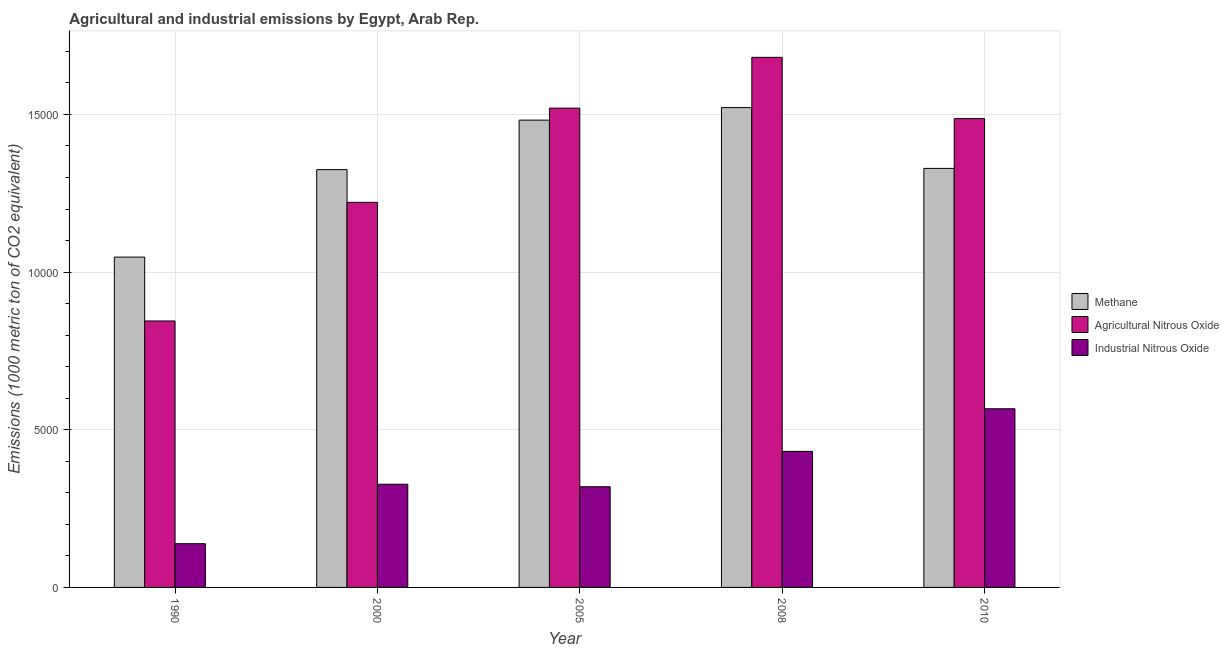How many groups of bars are there?
Give a very brief answer. 5. Are the number of bars per tick equal to the number of legend labels?
Keep it short and to the point. Yes. How many bars are there on the 3rd tick from the left?
Provide a succinct answer. 3. How many bars are there on the 5th tick from the right?
Make the answer very short. 3. What is the amount of methane emissions in 2000?
Offer a very short reply. 1.33e+04. Across all years, what is the maximum amount of agricultural nitrous oxide emissions?
Provide a succinct answer. 1.68e+04. Across all years, what is the minimum amount of agricultural nitrous oxide emissions?
Ensure brevity in your answer.  8449.9. What is the total amount of agricultural nitrous oxide emissions in the graph?
Provide a short and direct response. 6.75e+04. What is the difference between the amount of industrial nitrous oxide emissions in 1990 and that in 2000?
Ensure brevity in your answer.  -1886.1. What is the difference between the amount of agricultural nitrous oxide emissions in 2010 and the amount of methane emissions in 2005?
Make the answer very short. -331.2. What is the average amount of agricultural nitrous oxide emissions per year?
Offer a terse response. 1.35e+04. In how many years, is the amount of agricultural nitrous oxide emissions greater than 6000 metric ton?
Your answer should be compact. 5. What is the ratio of the amount of methane emissions in 2008 to that in 2010?
Your answer should be compact. 1.15. Is the amount of agricultural nitrous oxide emissions in 2005 less than that in 2008?
Make the answer very short. Yes. Is the difference between the amount of agricultural nitrous oxide emissions in 1990 and 2000 greater than the difference between the amount of methane emissions in 1990 and 2000?
Give a very brief answer. No. What is the difference between the highest and the second highest amount of agricultural nitrous oxide emissions?
Offer a very short reply. 1611.4. What is the difference between the highest and the lowest amount of agricultural nitrous oxide emissions?
Give a very brief answer. 8361.5. In how many years, is the amount of agricultural nitrous oxide emissions greater than the average amount of agricultural nitrous oxide emissions taken over all years?
Give a very brief answer. 3. Is the sum of the amount of methane emissions in 1990 and 2000 greater than the maximum amount of agricultural nitrous oxide emissions across all years?
Offer a terse response. Yes. What does the 1st bar from the left in 2010 represents?
Offer a very short reply. Methane. What does the 1st bar from the right in 2010 represents?
Offer a terse response. Industrial Nitrous Oxide. Is it the case that in every year, the sum of the amount of methane emissions and amount of agricultural nitrous oxide emissions is greater than the amount of industrial nitrous oxide emissions?
Offer a terse response. Yes. How many bars are there?
Your answer should be compact. 15. Does the graph contain any zero values?
Offer a terse response. No. How are the legend labels stacked?
Your response must be concise. Vertical. What is the title of the graph?
Your response must be concise. Agricultural and industrial emissions by Egypt, Arab Rep. What is the label or title of the X-axis?
Offer a very short reply. Year. What is the label or title of the Y-axis?
Provide a short and direct response. Emissions (1000 metric ton of CO2 equivalent). What is the Emissions (1000 metric ton of CO2 equivalent) of Methane in 1990?
Give a very brief answer. 1.05e+04. What is the Emissions (1000 metric ton of CO2 equivalent) in Agricultural Nitrous Oxide in 1990?
Make the answer very short. 8449.9. What is the Emissions (1000 metric ton of CO2 equivalent) in Industrial Nitrous Oxide in 1990?
Make the answer very short. 1386.6. What is the Emissions (1000 metric ton of CO2 equivalent) of Methane in 2000?
Your response must be concise. 1.33e+04. What is the Emissions (1000 metric ton of CO2 equivalent) in Agricultural Nitrous Oxide in 2000?
Offer a terse response. 1.22e+04. What is the Emissions (1000 metric ton of CO2 equivalent) of Industrial Nitrous Oxide in 2000?
Provide a succinct answer. 3272.7. What is the Emissions (1000 metric ton of CO2 equivalent) in Methane in 2005?
Provide a succinct answer. 1.48e+04. What is the Emissions (1000 metric ton of CO2 equivalent) of Agricultural Nitrous Oxide in 2005?
Offer a very short reply. 1.52e+04. What is the Emissions (1000 metric ton of CO2 equivalent) of Industrial Nitrous Oxide in 2005?
Offer a very short reply. 3192.6. What is the Emissions (1000 metric ton of CO2 equivalent) of Methane in 2008?
Provide a short and direct response. 1.52e+04. What is the Emissions (1000 metric ton of CO2 equivalent) in Agricultural Nitrous Oxide in 2008?
Your response must be concise. 1.68e+04. What is the Emissions (1000 metric ton of CO2 equivalent) in Industrial Nitrous Oxide in 2008?
Give a very brief answer. 4315. What is the Emissions (1000 metric ton of CO2 equivalent) in Methane in 2010?
Your answer should be compact. 1.33e+04. What is the Emissions (1000 metric ton of CO2 equivalent) in Agricultural Nitrous Oxide in 2010?
Provide a succinct answer. 1.49e+04. What is the Emissions (1000 metric ton of CO2 equivalent) of Industrial Nitrous Oxide in 2010?
Provide a short and direct response. 5666.2. Across all years, what is the maximum Emissions (1000 metric ton of CO2 equivalent) of Methane?
Offer a terse response. 1.52e+04. Across all years, what is the maximum Emissions (1000 metric ton of CO2 equivalent) of Agricultural Nitrous Oxide?
Your answer should be very brief. 1.68e+04. Across all years, what is the maximum Emissions (1000 metric ton of CO2 equivalent) in Industrial Nitrous Oxide?
Your answer should be compact. 5666.2. Across all years, what is the minimum Emissions (1000 metric ton of CO2 equivalent) in Methane?
Offer a terse response. 1.05e+04. Across all years, what is the minimum Emissions (1000 metric ton of CO2 equivalent) of Agricultural Nitrous Oxide?
Provide a succinct answer. 8449.9. Across all years, what is the minimum Emissions (1000 metric ton of CO2 equivalent) in Industrial Nitrous Oxide?
Give a very brief answer. 1386.6. What is the total Emissions (1000 metric ton of CO2 equivalent) of Methane in the graph?
Your answer should be very brief. 6.71e+04. What is the total Emissions (1000 metric ton of CO2 equivalent) of Agricultural Nitrous Oxide in the graph?
Ensure brevity in your answer.  6.75e+04. What is the total Emissions (1000 metric ton of CO2 equivalent) of Industrial Nitrous Oxide in the graph?
Ensure brevity in your answer.  1.78e+04. What is the difference between the Emissions (1000 metric ton of CO2 equivalent) in Methane in 1990 and that in 2000?
Provide a succinct answer. -2774.9. What is the difference between the Emissions (1000 metric ton of CO2 equivalent) of Agricultural Nitrous Oxide in 1990 and that in 2000?
Your answer should be compact. -3762.5. What is the difference between the Emissions (1000 metric ton of CO2 equivalent) in Industrial Nitrous Oxide in 1990 and that in 2000?
Provide a succinct answer. -1886.1. What is the difference between the Emissions (1000 metric ton of CO2 equivalent) of Methane in 1990 and that in 2005?
Give a very brief answer. -4343.8. What is the difference between the Emissions (1000 metric ton of CO2 equivalent) of Agricultural Nitrous Oxide in 1990 and that in 2005?
Give a very brief answer. -6750.1. What is the difference between the Emissions (1000 metric ton of CO2 equivalent) of Industrial Nitrous Oxide in 1990 and that in 2005?
Provide a succinct answer. -1806. What is the difference between the Emissions (1000 metric ton of CO2 equivalent) of Methane in 1990 and that in 2008?
Provide a succinct answer. -4741.1. What is the difference between the Emissions (1000 metric ton of CO2 equivalent) in Agricultural Nitrous Oxide in 1990 and that in 2008?
Provide a short and direct response. -8361.5. What is the difference between the Emissions (1000 metric ton of CO2 equivalent) of Industrial Nitrous Oxide in 1990 and that in 2008?
Provide a short and direct response. -2928.4. What is the difference between the Emissions (1000 metric ton of CO2 equivalent) in Methane in 1990 and that in 2010?
Provide a short and direct response. -2813. What is the difference between the Emissions (1000 metric ton of CO2 equivalent) of Agricultural Nitrous Oxide in 1990 and that in 2010?
Make the answer very short. -6418.9. What is the difference between the Emissions (1000 metric ton of CO2 equivalent) in Industrial Nitrous Oxide in 1990 and that in 2010?
Keep it short and to the point. -4279.6. What is the difference between the Emissions (1000 metric ton of CO2 equivalent) of Methane in 2000 and that in 2005?
Your answer should be compact. -1568.9. What is the difference between the Emissions (1000 metric ton of CO2 equivalent) in Agricultural Nitrous Oxide in 2000 and that in 2005?
Provide a succinct answer. -2987.6. What is the difference between the Emissions (1000 metric ton of CO2 equivalent) in Industrial Nitrous Oxide in 2000 and that in 2005?
Keep it short and to the point. 80.1. What is the difference between the Emissions (1000 metric ton of CO2 equivalent) in Methane in 2000 and that in 2008?
Keep it short and to the point. -1966.2. What is the difference between the Emissions (1000 metric ton of CO2 equivalent) of Agricultural Nitrous Oxide in 2000 and that in 2008?
Provide a short and direct response. -4599. What is the difference between the Emissions (1000 metric ton of CO2 equivalent) of Industrial Nitrous Oxide in 2000 and that in 2008?
Offer a terse response. -1042.3. What is the difference between the Emissions (1000 metric ton of CO2 equivalent) in Methane in 2000 and that in 2010?
Provide a succinct answer. -38.1. What is the difference between the Emissions (1000 metric ton of CO2 equivalent) of Agricultural Nitrous Oxide in 2000 and that in 2010?
Provide a short and direct response. -2656.4. What is the difference between the Emissions (1000 metric ton of CO2 equivalent) of Industrial Nitrous Oxide in 2000 and that in 2010?
Ensure brevity in your answer.  -2393.5. What is the difference between the Emissions (1000 metric ton of CO2 equivalent) of Methane in 2005 and that in 2008?
Your answer should be compact. -397.3. What is the difference between the Emissions (1000 metric ton of CO2 equivalent) in Agricultural Nitrous Oxide in 2005 and that in 2008?
Keep it short and to the point. -1611.4. What is the difference between the Emissions (1000 metric ton of CO2 equivalent) of Industrial Nitrous Oxide in 2005 and that in 2008?
Offer a very short reply. -1122.4. What is the difference between the Emissions (1000 metric ton of CO2 equivalent) in Methane in 2005 and that in 2010?
Make the answer very short. 1530.8. What is the difference between the Emissions (1000 metric ton of CO2 equivalent) of Agricultural Nitrous Oxide in 2005 and that in 2010?
Your answer should be compact. 331.2. What is the difference between the Emissions (1000 metric ton of CO2 equivalent) in Industrial Nitrous Oxide in 2005 and that in 2010?
Your answer should be compact. -2473.6. What is the difference between the Emissions (1000 metric ton of CO2 equivalent) of Methane in 2008 and that in 2010?
Give a very brief answer. 1928.1. What is the difference between the Emissions (1000 metric ton of CO2 equivalent) of Agricultural Nitrous Oxide in 2008 and that in 2010?
Offer a terse response. 1942.6. What is the difference between the Emissions (1000 metric ton of CO2 equivalent) in Industrial Nitrous Oxide in 2008 and that in 2010?
Offer a terse response. -1351.2. What is the difference between the Emissions (1000 metric ton of CO2 equivalent) of Methane in 1990 and the Emissions (1000 metric ton of CO2 equivalent) of Agricultural Nitrous Oxide in 2000?
Your answer should be very brief. -1736.3. What is the difference between the Emissions (1000 metric ton of CO2 equivalent) in Methane in 1990 and the Emissions (1000 metric ton of CO2 equivalent) in Industrial Nitrous Oxide in 2000?
Provide a succinct answer. 7203.4. What is the difference between the Emissions (1000 metric ton of CO2 equivalent) in Agricultural Nitrous Oxide in 1990 and the Emissions (1000 metric ton of CO2 equivalent) in Industrial Nitrous Oxide in 2000?
Provide a succinct answer. 5177.2. What is the difference between the Emissions (1000 metric ton of CO2 equivalent) of Methane in 1990 and the Emissions (1000 metric ton of CO2 equivalent) of Agricultural Nitrous Oxide in 2005?
Offer a terse response. -4723.9. What is the difference between the Emissions (1000 metric ton of CO2 equivalent) in Methane in 1990 and the Emissions (1000 metric ton of CO2 equivalent) in Industrial Nitrous Oxide in 2005?
Offer a terse response. 7283.5. What is the difference between the Emissions (1000 metric ton of CO2 equivalent) of Agricultural Nitrous Oxide in 1990 and the Emissions (1000 metric ton of CO2 equivalent) of Industrial Nitrous Oxide in 2005?
Ensure brevity in your answer.  5257.3. What is the difference between the Emissions (1000 metric ton of CO2 equivalent) of Methane in 1990 and the Emissions (1000 metric ton of CO2 equivalent) of Agricultural Nitrous Oxide in 2008?
Keep it short and to the point. -6335.3. What is the difference between the Emissions (1000 metric ton of CO2 equivalent) in Methane in 1990 and the Emissions (1000 metric ton of CO2 equivalent) in Industrial Nitrous Oxide in 2008?
Keep it short and to the point. 6161.1. What is the difference between the Emissions (1000 metric ton of CO2 equivalent) of Agricultural Nitrous Oxide in 1990 and the Emissions (1000 metric ton of CO2 equivalent) of Industrial Nitrous Oxide in 2008?
Provide a short and direct response. 4134.9. What is the difference between the Emissions (1000 metric ton of CO2 equivalent) of Methane in 1990 and the Emissions (1000 metric ton of CO2 equivalent) of Agricultural Nitrous Oxide in 2010?
Your answer should be very brief. -4392.7. What is the difference between the Emissions (1000 metric ton of CO2 equivalent) in Methane in 1990 and the Emissions (1000 metric ton of CO2 equivalent) in Industrial Nitrous Oxide in 2010?
Your answer should be very brief. 4809.9. What is the difference between the Emissions (1000 metric ton of CO2 equivalent) of Agricultural Nitrous Oxide in 1990 and the Emissions (1000 metric ton of CO2 equivalent) of Industrial Nitrous Oxide in 2010?
Your answer should be very brief. 2783.7. What is the difference between the Emissions (1000 metric ton of CO2 equivalent) of Methane in 2000 and the Emissions (1000 metric ton of CO2 equivalent) of Agricultural Nitrous Oxide in 2005?
Give a very brief answer. -1949. What is the difference between the Emissions (1000 metric ton of CO2 equivalent) in Methane in 2000 and the Emissions (1000 metric ton of CO2 equivalent) in Industrial Nitrous Oxide in 2005?
Provide a succinct answer. 1.01e+04. What is the difference between the Emissions (1000 metric ton of CO2 equivalent) of Agricultural Nitrous Oxide in 2000 and the Emissions (1000 metric ton of CO2 equivalent) of Industrial Nitrous Oxide in 2005?
Ensure brevity in your answer.  9019.8. What is the difference between the Emissions (1000 metric ton of CO2 equivalent) of Methane in 2000 and the Emissions (1000 metric ton of CO2 equivalent) of Agricultural Nitrous Oxide in 2008?
Your answer should be compact. -3560.4. What is the difference between the Emissions (1000 metric ton of CO2 equivalent) of Methane in 2000 and the Emissions (1000 metric ton of CO2 equivalent) of Industrial Nitrous Oxide in 2008?
Your answer should be very brief. 8936. What is the difference between the Emissions (1000 metric ton of CO2 equivalent) in Agricultural Nitrous Oxide in 2000 and the Emissions (1000 metric ton of CO2 equivalent) in Industrial Nitrous Oxide in 2008?
Your answer should be very brief. 7897.4. What is the difference between the Emissions (1000 metric ton of CO2 equivalent) of Methane in 2000 and the Emissions (1000 metric ton of CO2 equivalent) of Agricultural Nitrous Oxide in 2010?
Your answer should be very brief. -1617.8. What is the difference between the Emissions (1000 metric ton of CO2 equivalent) in Methane in 2000 and the Emissions (1000 metric ton of CO2 equivalent) in Industrial Nitrous Oxide in 2010?
Your answer should be very brief. 7584.8. What is the difference between the Emissions (1000 metric ton of CO2 equivalent) of Agricultural Nitrous Oxide in 2000 and the Emissions (1000 metric ton of CO2 equivalent) of Industrial Nitrous Oxide in 2010?
Offer a terse response. 6546.2. What is the difference between the Emissions (1000 metric ton of CO2 equivalent) of Methane in 2005 and the Emissions (1000 metric ton of CO2 equivalent) of Agricultural Nitrous Oxide in 2008?
Ensure brevity in your answer.  -1991.5. What is the difference between the Emissions (1000 metric ton of CO2 equivalent) of Methane in 2005 and the Emissions (1000 metric ton of CO2 equivalent) of Industrial Nitrous Oxide in 2008?
Offer a very short reply. 1.05e+04. What is the difference between the Emissions (1000 metric ton of CO2 equivalent) in Agricultural Nitrous Oxide in 2005 and the Emissions (1000 metric ton of CO2 equivalent) in Industrial Nitrous Oxide in 2008?
Provide a short and direct response. 1.09e+04. What is the difference between the Emissions (1000 metric ton of CO2 equivalent) in Methane in 2005 and the Emissions (1000 metric ton of CO2 equivalent) in Agricultural Nitrous Oxide in 2010?
Offer a terse response. -48.9. What is the difference between the Emissions (1000 metric ton of CO2 equivalent) of Methane in 2005 and the Emissions (1000 metric ton of CO2 equivalent) of Industrial Nitrous Oxide in 2010?
Give a very brief answer. 9153.7. What is the difference between the Emissions (1000 metric ton of CO2 equivalent) of Agricultural Nitrous Oxide in 2005 and the Emissions (1000 metric ton of CO2 equivalent) of Industrial Nitrous Oxide in 2010?
Provide a short and direct response. 9533.8. What is the difference between the Emissions (1000 metric ton of CO2 equivalent) in Methane in 2008 and the Emissions (1000 metric ton of CO2 equivalent) in Agricultural Nitrous Oxide in 2010?
Keep it short and to the point. 348.4. What is the difference between the Emissions (1000 metric ton of CO2 equivalent) in Methane in 2008 and the Emissions (1000 metric ton of CO2 equivalent) in Industrial Nitrous Oxide in 2010?
Your response must be concise. 9551. What is the difference between the Emissions (1000 metric ton of CO2 equivalent) of Agricultural Nitrous Oxide in 2008 and the Emissions (1000 metric ton of CO2 equivalent) of Industrial Nitrous Oxide in 2010?
Offer a very short reply. 1.11e+04. What is the average Emissions (1000 metric ton of CO2 equivalent) in Methane per year?
Ensure brevity in your answer.  1.34e+04. What is the average Emissions (1000 metric ton of CO2 equivalent) of Agricultural Nitrous Oxide per year?
Make the answer very short. 1.35e+04. What is the average Emissions (1000 metric ton of CO2 equivalent) in Industrial Nitrous Oxide per year?
Provide a succinct answer. 3566.62. In the year 1990, what is the difference between the Emissions (1000 metric ton of CO2 equivalent) in Methane and Emissions (1000 metric ton of CO2 equivalent) in Agricultural Nitrous Oxide?
Ensure brevity in your answer.  2026.2. In the year 1990, what is the difference between the Emissions (1000 metric ton of CO2 equivalent) in Methane and Emissions (1000 metric ton of CO2 equivalent) in Industrial Nitrous Oxide?
Keep it short and to the point. 9089.5. In the year 1990, what is the difference between the Emissions (1000 metric ton of CO2 equivalent) in Agricultural Nitrous Oxide and Emissions (1000 metric ton of CO2 equivalent) in Industrial Nitrous Oxide?
Your response must be concise. 7063.3. In the year 2000, what is the difference between the Emissions (1000 metric ton of CO2 equivalent) in Methane and Emissions (1000 metric ton of CO2 equivalent) in Agricultural Nitrous Oxide?
Offer a terse response. 1038.6. In the year 2000, what is the difference between the Emissions (1000 metric ton of CO2 equivalent) in Methane and Emissions (1000 metric ton of CO2 equivalent) in Industrial Nitrous Oxide?
Give a very brief answer. 9978.3. In the year 2000, what is the difference between the Emissions (1000 metric ton of CO2 equivalent) in Agricultural Nitrous Oxide and Emissions (1000 metric ton of CO2 equivalent) in Industrial Nitrous Oxide?
Ensure brevity in your answer.  8939.7. In the year 2005, what is the difference between the Emissions (1000 metric ton of CO2 equivalent) of Methane and Emissions (1000 metric ton of CO2 equivalent) of Agricultural Nitrous Oxide?
Provide a short and direct response. -380.1. In the year 2005, what is the difference between the Emissions (1000 metric ton of CO2 equivalent) of Methane and Emissions (1000 metric ton of CO2 equivalent) of Industrial Nitrous Oxide?
Keep it short and to the point. 1.16e+04. In the year 2005, what is the difference between the Emissions (1000 metric ton of CO2 equivalent) in Agricultural Nitrous Oxide and Emissions (1000 metric ton of CO2 equivalent) in Industrial Nitrous Oxide?
Provide a short and direct response. 1.20e+04. In the year 2008, what is the difference between the Emissions (1000 metric ton of CO2 equivalent) of Methane and Emissions (1000 metric ton of CO2 equivalent) of Agricultural Nitrous Oxide?
Make the answer very short. -1594.2. In the year 2008, what is the difference between the Emissions (1000 metric ton of CO2 equivalent) of Methane and Emissions (1000 metric ton of CO2 equivalent) of Industrial Nitrous Oxide?
Ensure brevity in your answer.  1.09e+04. In the year 2008, what is the difference between the Emissions (1000 metric ton of CO2 equivalent) of Agricultural Nitrous Oxide and Emissions (1000 metric ton of CO2 equivalent) of Industrial Nitrous Oxide?
Provide a short and direct response. 1.25e+04. In the year 2010, what is the difference between the Emissions (1000 metric ton of CO2 equivalent) in Methane and Emissions (1000 metric ton of CO2 equivalent) in Agricultural Nitrous Oxide?
Offer a terse response. -1579.7. In the year 2010, what is the difference between the Emissions (1000 metric ton of CO2 equivalent) in Methane and Emissions (1000 metric ton of CO2 equivalent) in Industrial Nitrous Oxide?
Your answer should be compact. 7622.9. In the year 2010, what is the difference between the Emissions (1000 metric ton of CO2 equivalent) in Agricultural Nitrous Oxide and Emissions (1000 metric ton of CO2 equivalent) in Industrial Nitrous Oxide?
Your response must be concise. 9202.6. What is the ratio of the Emissions (1000 metric ton of CO2 equivalent) in Methane in 1990 to that in 2000?
Make the answer very short. 0.79. What is the ratio of the Emissions (1000 metric ton of CO2 equivalent) in Agricultural Nitrous Oxide in 1990 to that in 2000?
Keep it short and to the point. 0.69. What is the ratio of the Emissions (1000 metric ton of CO2 equivalent) in Industrial Nitrous Oxide in 1990 to that in 2000?
Offer a very short reply. 0.42. What is the ratio of the Emissions (1000 metric ton of CO2 equivalent) in Methane in 1990 to that in 2005?
Make the answer very short. 0.71. What is the ratio of the Emissions (1000 metric ton of CO2 equivalent) in Agricultural Nitrous Oxide in 1990 to that in 2005?
Ensure brevity in your answer.  0.56. What is the ratio of the Emissions (1000 metric ton of CO2 equivalent) in Industrial Nitrous Oxide in 1990 to that in 2005?
Make the answer very short. 0.43. What is the ratio of the Emissions (1000 metric ton of CO2 equivalent) of Methane in 1990 to that in 2008?
Offer a very short reply. 0.69. What is the ratio of the Emissions (1000 metric ton of CO2 equivalent) in Agricultural Nitrous Oxide in 1990 to that in 2008?
Your answer should be very brief. 0.5. What is the ratio of the Emissions (1000 metric ton of CO2 equivalent) in Industrial Nitrous Oxide in 1990 to that in 2008?
Ensure brevity in your answer.  0.32. What is the ratio of the Emissions (1000 metric ton of CO2 equivalent) of Methane in 1990 to that in 2010?
Your answer should be compact. 0.79. What is the ratio of the Emissions (1000 metric ton of CO2 equivalent) in Agricultural Nitrous Oxide in 1990 to that in 2010?
Give a very brief answer. 0.57. What is the ratio of the Emissions (1000 metric ton of CO2 equivalent) in Industrial Nitrous Oxide in 1990 to that in 2010?
Offer a very short reply. 0.24. What is the ratio of the Emissions (1000 metric ton of CO2 equivalent) of Methane in 2000 to that in 2005?
Make the answer very short. 0.89. What is the ratio of the Emissions (1000 metric ton of CO2 equivalent) in Agricultural Nitrous Oxide in 2000 to that in 2005?
Your answer should be compact. 0.8. What is the ratio of the Emissions (1000 metric ton of CO2 equivalent) of Industrial Nitrous Oxide in 2000 to that in 2005?
Make the answer very short. 1.03. What is the ratio of the Emissions (1000 metric ton of CO2 equivalent) of Methane in 2000 to that in 2008?
Your answer should be very brief. 0.87. What is the ratio of the Emissions (1000 metric ton of CO2 equivalent) of Agricultural Nitrous Oxide in 2000 to that in 2008?
Your answer should be very brief. 0.73. What is the ratio of the Emissions (1000 metric ton of CO2 equivalent) in Industrial Nitrous Oxide in 2000 to that in 2008?
Give a very brief answer. 0.76. What is the ratio of the Emissions (1000 metric ton of CO2 equivalent) in Methane in 2000 to that in 2010?
Provide a succinct answer. 1. What is the ratio of the Emissions (1000 metric ton of CO2 equivalent) of Agricultural Nitrous Oxide in 2000 to that in 2010?
Make the answer very short. 0.82. What is the ratio of the Emissions (1000 metric ton of CO2 equivalent) in Industrial Nitrous Oxide in 2000 to that in 2010?
Make the answer very short. 0.58. What is the ratio of the Emissions (1000 metric ton of CO2 equivalent) in Methane in 2005 to that in 2008?
Offer a very short reply. 0.97. What is the ratio of the Emissions (1000 metric ton of CO2 equivalent) in Agricultural Nitrous Oxide in 2005 to that in 2008?
Your answer should be compact. 0.9. What is the ratio of the Emissions (1000 metric ton of CO2 equivalent) in Industrial Nitrous Oxide in 2005 to that in 2008?
Provide a short and direct response. 0.74. What is the ratio of the Emissions (1000 metric ton of CO2 equivalent) of Methane in 2005 to that in 2010?
Your answer should be very brief. 1.12. What is the ratio of the Emissions (1000 metric ton of CO2 equivalent) of Agricultural Nitrous Oxide in 2005 to that in 2010?
Your answer should be very brief. 1.02. What is the ratio of the Emissions (1000 metric ton of CO2 equivalent) of Industrial Nitrous Oxide in 2005 to that in 2010?
Your response must be concise. 0.56. What is the ratio of the Emissions (1000 metric ton of CO2 equivalent) in Methane in 2008 to that in 2010?
Provide a short and direct response. 1.15. What is the ratio of the Emissions (1000 metric ton of CO2 equivalent) of Agricultural Nitrous Oxide in 2008 to that in 2010?
Keep it short and to the point. 1.13. What is the ratio of the Emissions (1000 metric ton of CO2 equivalent) of Industrial Nitrous Oxide in 2008 to that in 2010?
Make the answer very short. 0.76. What is the difference between the highest and the second highest Emissions (1000 metric ton of CO2 equivalent) in Methane?
Your answer should be compact. 397.3. What is the difference between the highest and the second highest Emissions (1000 metric ton of CO2 equivalent) of Agricultural Nitrous Oxide?
Offer a terse response. 1611.4. What is the difference between the highest and the second highest Emissions (1000 metric ton of CO2 equivalent) of Industrial Nitrous Oxide?
Ensure brevity in your answer.  1351.2. What is the difference between the highest and the lowest Emissions (1000 metric ton of CO2 equivalent) in Methane?
Offer a very short reply. 4741.1. What is the difference between the highest and the lowest Emissions (1000 metric ton of CO2 equivalent) of Agricultural Nitrous Oxide?
Offer a very short reply. 8361.5. What is the difference between the highest and the lowest Emissions (1000 metric ton of CO2 equivalent) of Industrial Nitrous Oxide?
Ensure brevity in your answer.  4279.6. 